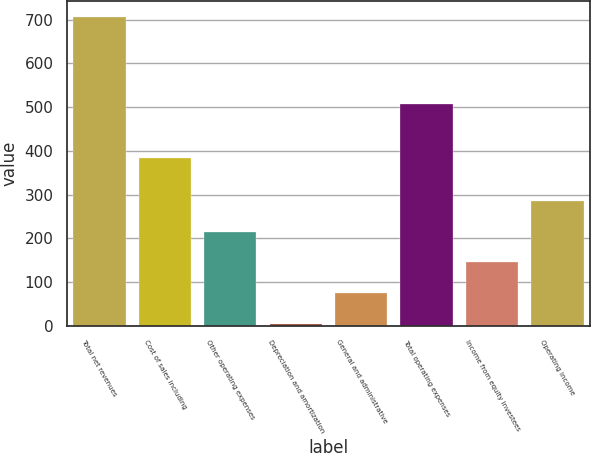Convert chart to OTSL. <chart><loc_0><loc_0><loc_500><loc_500><bar_chart><fcel>Total net revenues<fcel>Cost of sales including<fcel>Other operating expenses<fcel>Depreciation and amortization<fcel>General and administrative<fcel>Total operating expenses<fcel>Income from equity investees<fcel>Operating income<nl><fcel>707.4<fcel>383.2<fcel>214.81<fcel>3.7<fcel>74.07<fcel>507<fcel>144.44<fcel>285.18<nl></chart> 